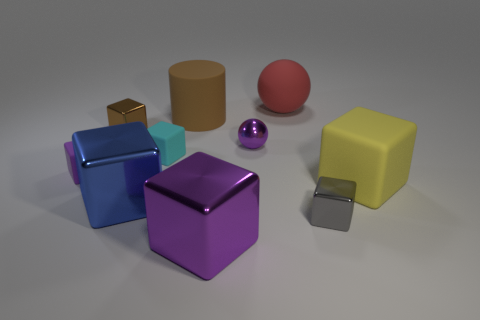Subtract all red cylinders. How many purple blocks are left? 2 Subtract 3 blocks. How many blocks are left? 4 Subtract all yellow cubes. How many cubes are left? 6 Subtract all blue cubes. How many cubes are left? 6 Subtract all yellow blocks. Subtract all purple spheres. How many blocks are left? 6 Subtract all spheres. How many objects are left? 8 Subtract all tiny purple metal blocks. Subtract all matte cubes. How many objects are left? 7 Add 6 metal balls. How many metal balls are left? 7 Add 7 large yellow blocks. How many large yellow blocks exist? 8 Subtract 1 gray blocks. How many objects are left? 9 